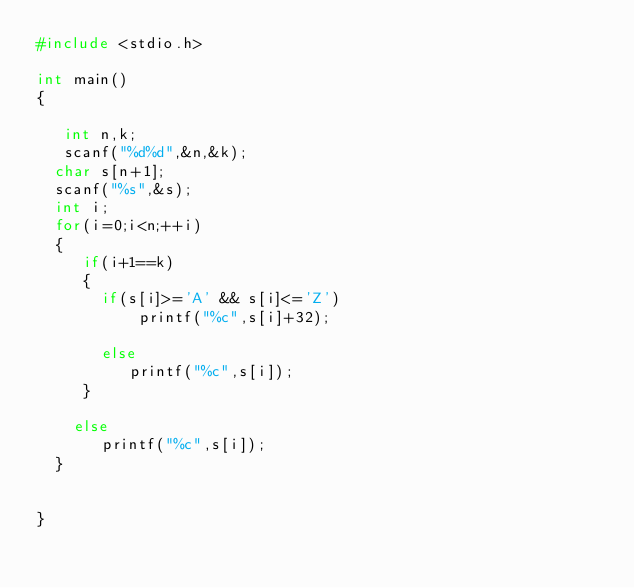Convert code to text. <code><loc_0><loc_0><loc_500><loc_500><_C_>#include <stdio.h>
 
int main()
{
 
   int n,k;
   scanf("%d%d",&n,&k);
  char s[n+1];
  scanf("%s",&s);
  int i;
  for(i=0;i<n;++i)
  {
     if(i+1==k)
     {
       if(s[i]>='A' && s[i]<='Z')
           printf("%c",s[i]+32);
       
       else
          printf("%c",s[i]);
     }
    
    else
       printf("%c",s[i]);
  }
  
  
}</code> 